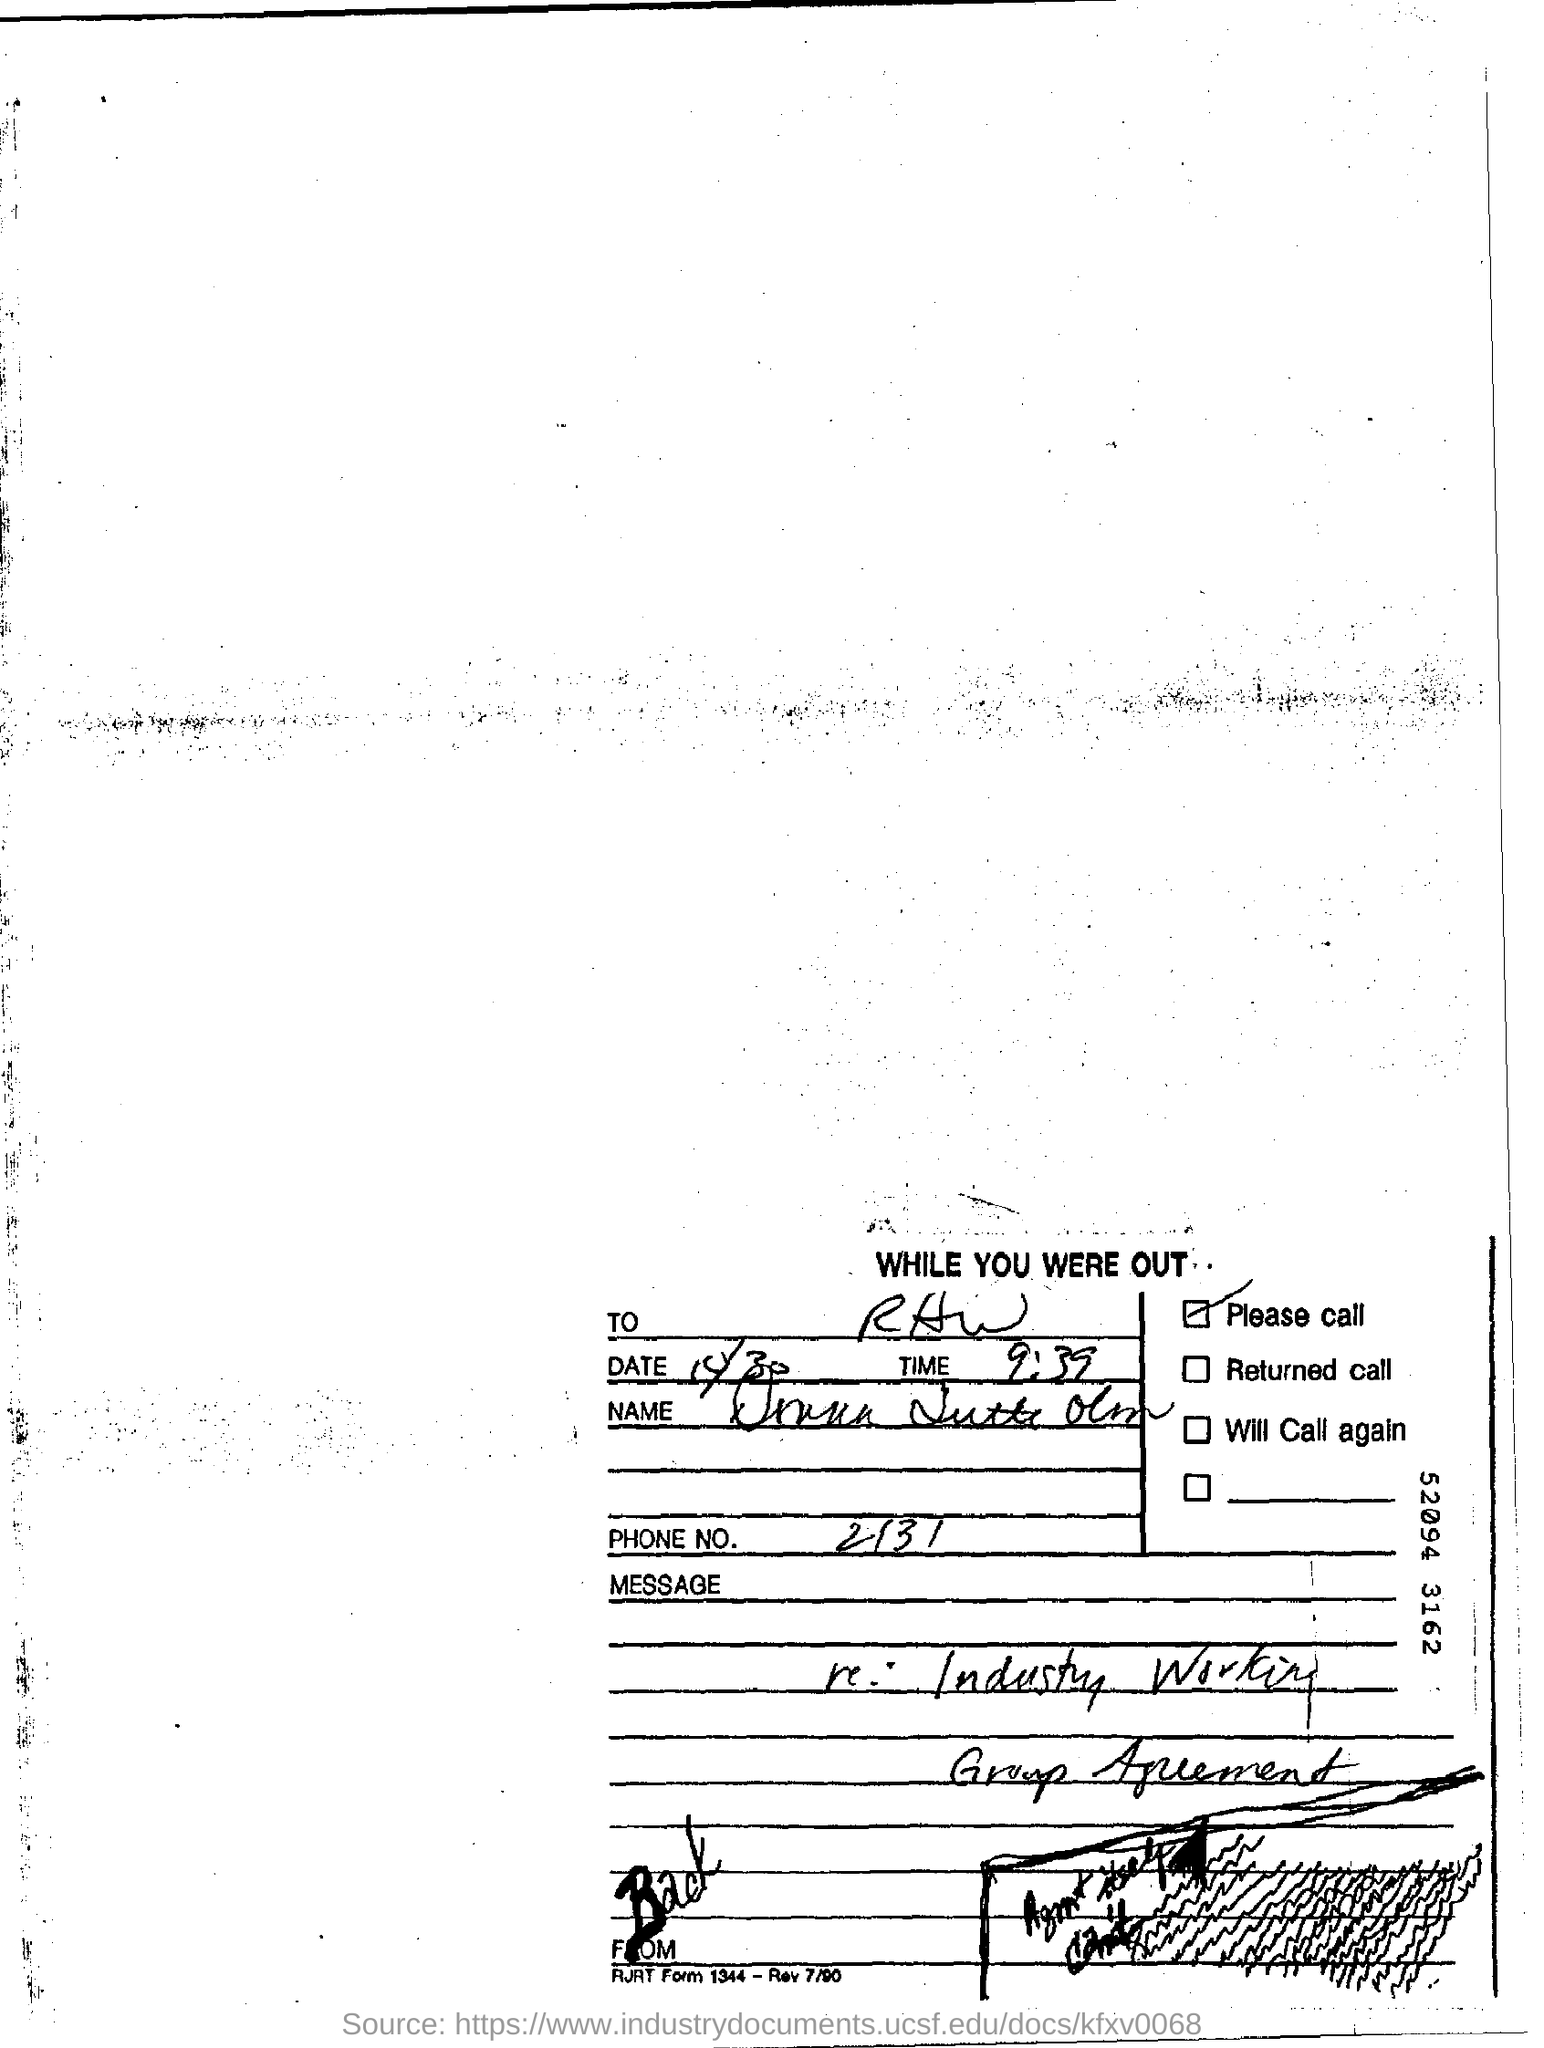Highlight a few significant elements in this photo. The phone number is 2131... It is currently 9:39. 